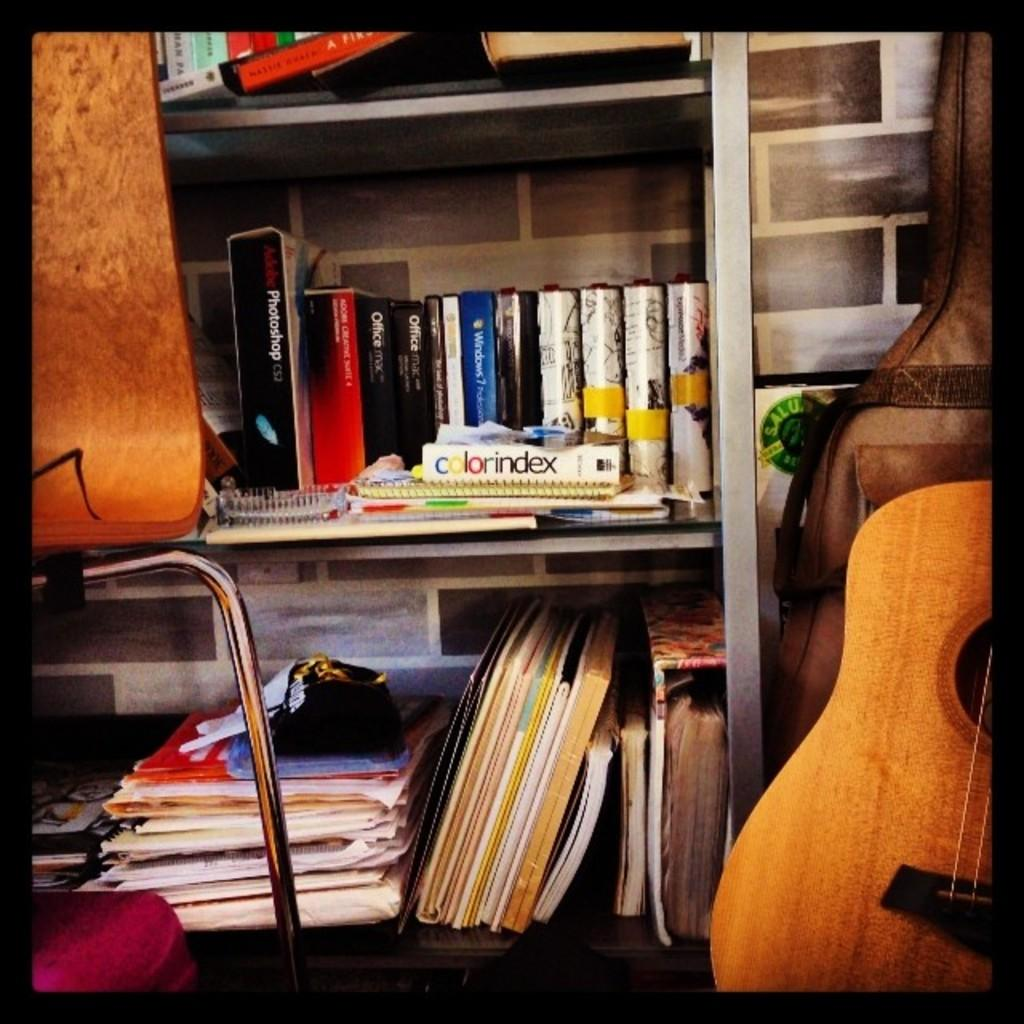What type of furniture is present in the image? There is a bookshelf in the image. What musical instrument can be seen in the image? There is a guitar on the side in the image. How many birds are sitting on the guitar in the image? There are no birds present in the image, so it is not possible to determine how many might be sitting on the guitar. 